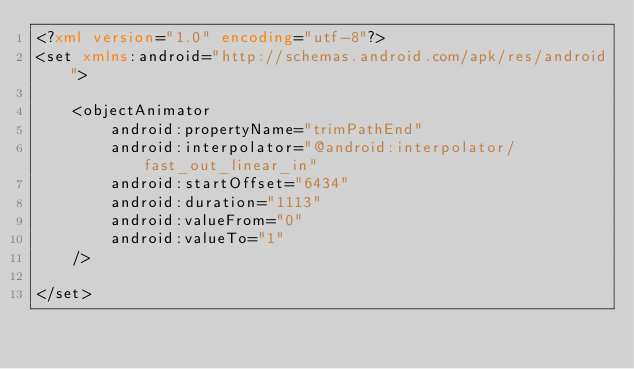<code> <loc_0><loc_0><loc_500><loc_500><_XML_><?xml version="1.0" encoding="utf-8"?>
<set xmlns:android="http://schemas.android.com/apk/res/android">

    <objectAnimator
        android:propertyName="trimPathEnd"
        android:interpolator="@android:interpolator/fast_out_linear_in"
        android:startOffset="6434"
        android:duration="1113"
        android:valueFrom="0"
        android:valueTo="1"
    />

</set></code> 